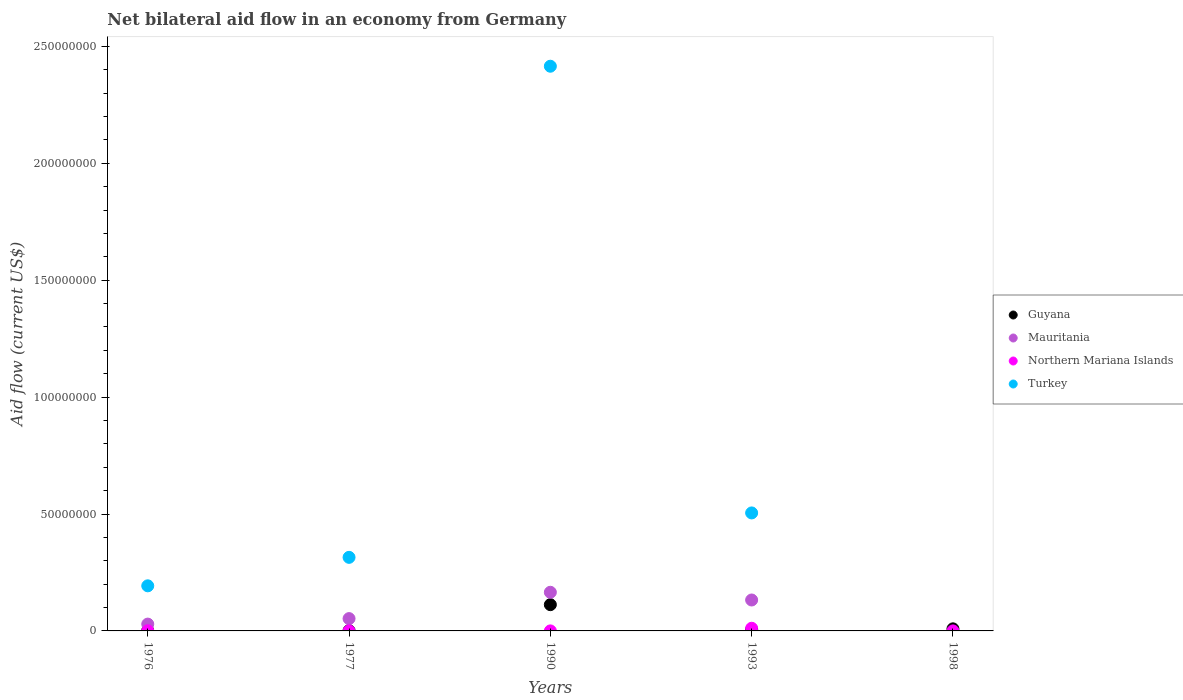What is the net bilateral aid flow in Mauritania in 1993?
Offer a terse response. 1.32e+07. Across all years, what is the maximum net bilateral aid flow in Northern Mariana Islands?
Offer a terse response. 1.14e+06. Across all years, what is the minimum net bilateral aid flow in Guyana?
Give a very brief answer. 1.20e+05. What is the total net bilateral aid flow in Northern Mariana Islands in the graph?
Your answer should be compact. 1.24e+06. What is the difference between the net bilateral aid flow in Turkey in 1976 and that in 1990?
Offer a very short reply. -2.22e+08. What is the difference between the net bilateral aid flow in Guyana in 1998 and the net bilateral aid flow in Northern Mariana Islands in 1977?
Provide a short and direct response. 8.80e+05. What is the average net bilateral aid flow in Northern Mariana Islands per year?
Make the answer very short. 2.48e+05. In the year 1993, what is the difference between the net bilateral aid flow in Mauritania and net bilateral aid flow in Guyana?
Your answer should be very brief. 1.27e+07. In how many years, is the net bilateral aid flow in Turkey greater than 140000000 US$?
Make the answer very short. 1. What is the ratio of the net bilateral aid flow in Turkey in 1976 to that in 1990?
Your answer should be very brief. 0.08. Is the difference between the net bilateral aid flow in Mauritania in 1976 and 1977 greater than the difference between the net bilateral aid flow in Guyana in 1976 and 1977?
Give a very brief answer. No. What is the difference between the highest and the second highest net bilateral aid flow in Northern Mariana Islands?
Give a very brief answer. 1.07e+06. What is the difference between the highest and the lowest net bilateral aid flow in Guyana?
Your response must be concise. 1.11e+07. In how many years, is the net bilateral aid flow in Turkey greater than the average net bilateral aid flow in Turkey taken over all years?
Ensure brevity in your answer.  1. Is the sum of the net bilateral aid flow in Turkey in 1990 and 1993 greater than the maximum net bilateral aid flow in Northern Mariana Islands across all years?
Your answer should be very brief. Yes. Does the net bilateral aid flow in Guyana monotonically increase over the years?
Provide a short and direct response. No. How many dotlines are there?
Your answer should be very brief. 4. How many years are there in the graph?
Give a very brief answer. 5. Are the values on the major ticks of Y-axis written in scientific E-notation?
Provide a succinct answer. No. Does the graph contain any zero values?
Offer a terse response. Yes. What is the title of the graph?
Your response must be concise. Net bilateral aid flow in an economy from Germany. Does "Singapore" appear as one of the legend labels in the graph?
Provide a succinct answer. No. What is the label or title of the X-axis?
Ensure brevity in your answer.  Years. What is the label or title of the Y-axis?
Offer a very short reply. Aid flow (current US$). What is the Aid flow (current US$) in Mauritania in 1976?
Your answer should be compact. 2.92e+06. What is the Aid flow (current US$) in Turkey in 1976?
Keep it short and to the point. 1.93e+07. What is the Aid flow (current US$) of Guyana in 1977?
Offer a very short reply. 1.20e+05. What is the Aid flow (current US$) of Mauritania in 1977?
Keep it short and to the point. 5.27e+06. What is the Aid flow (current US$) of Turkey in 1977?
Provide a short and direct response. 3.15e+07. What is the Aid flow (current US$) in Guyana in 1990?
Keep it short and to the point. 1.12e+07. What is the Aid flow (current US$) of Mauritania in 1990?
Keep it short and to the point. 1.65e+07. What is the Aid flow (current US$) in Northern Mariana Islands in 1990?
Provide a succinct answer. 10000. What is the Aid flow (current US$) in Turkey in 1990?
Your answer should be compact. 2.42e+08. What is the Aid flow (current US$) in Guyana in 1993?
Make the answer very short. 5.20e+05. What is the Aid flow (current US$) of Mauritania in 1993?
Your answer should be very brief. 1.32e+07. What is the Aid flow (current US$) in Northern Mariana Islands in 1993?
Ensure brevity in your answer.  1.14e+06. What is the Aid flow (current US$) in Turkey in 1993?
Ensure brevity in your answer.  5.05e+07. What is the Aid flow (current US$) of Guyana in 1998?
Ensure brevity in your answer.  8.90e+05. Across all years, what is the maximum Aid flow (current US$) of Guyana?
Ensure brevity in your answer.  1.12e+07. Across all years, what is the maximum Aid flow (current US$) in Mauritania?
Keep it short and to the point. 1.65e+07. Across all years, what is the maximum Aid flow (current US$) in Northern Mariana Islands?
Your response must be concise. 1.14e+06. Across all years, what is the maximum Aid flow (current US$) in Turkey?
Provide a short and direct response. 2.42e+08. Across all years, what is the minimum Aid flow (current US$) of Guyana?
Give a very brief answer. 1.20e+05. Across all years, what is the minimum Aid flow (current US$) of Northern Mariana Islands?
Give a very brief answer. 10000. What is the total Aid flow (current US$) in Guyana in the graph?
Provide a short and direct response. 1.29e+07. What is the total Aid flow (current US$) of Mauritania in the graph?
Make the answer very short. 3.80e+07. What is the total Aid flow (current US$) in Northern Mariana Islands in the graph?
Your answer should be compact. 1.24e+06. What is the total Aid flow (current US$) in Turkey in the graph?
Offer a terse response. 3.43e+08. What is the difference between the Aid flow (current US$) in Guyana in 1976 and that in 1977?
Give a very brief answer. 3.00e+04. What is the difference between the Aid flow (current US$) of Mauritania in 1976 and that in 1977?
Make the answer very short. -2.35e+06. What is the difference between the Aid flow (current US$) in Northern Mariana Islands in 1976 and that in 1977?
Make the answer very short. 6.00e+04. What is the difference between the Aid flow (current US$) of Turkey in 1976 and that in 1977?
Your response must be concise. -1.22e+07. What is the difference between the Aid flow (current US$) of Guyana in 1976 and that in 1990?
Your answer should be compact. -1.11e+07. What is the difference between the Aid flow (current US$) of Mauritania in 1976 and that in 1990?
Ensure brevity in your answer.  -1.36e+07. What is the difference between the Aid flow (current US$) of Northern Mariana Islands in 1976 and that in 1990?
Your answer should be compact. 6.00e+04. What is the difference between the Aid flow (current US$) in Turkey in 1976 and that in 1990?
Make the answer very short. -2.22e+08. What is the difference between the Aid flow (current US$) in Guyana in 1976 and that in 1993?
Your answer should be very brief. -3.70e+05. What is the difference between the Aid flow (current US$) in Mauritania in 1976 and that in 1993?
Provide a short and direct response. -1.03e+07. What is the difference between the Aid flow (current US$) of Northern Mariana Islands in 1976 and that in 1993?
Provide a short and direct response. -1.07e+06. What is the difference between the Aid flow (current US$) in Turkey in 1976 and that in 1993?
Give a very brief answer. -3.12e+07. What is the difference between the Aid flow (current US$) of Guyana in 1976 and that in 1998?
Ensure brevity in your answer.  -7.40e+05. What is the difference between the Aid flow (current US$) in Guyana in 1977 and that in 1990?
Make the answer very short. -1.11e+07. What is the difference between the Aid flow (current US$) in Mauritania in 1977 and that in 1990?
Ensure brevity in your answer.  -1.13e+07. What is the difference between the Aid flow (current US$) of Northern Mariana Islands in 1977 and that in 1990?
Provide a succinct answer. 0. What is the difference between the Aid flow (current US$) in Turkey in 1977 and that in 1990?
Your response must be concise. -2.10e+08. What is the difference between the Aid flow (current US$) of Guyana in 1977 and that in 1993?
Your answer should be compact. -4.00e+05. What is the difference between the Aid flow (current US$) in Mauritania in 1977 and that in 1993?
Provide a short and direct response. -7.96e+06. What is the difference between the Aid flow (current US$) of Northern Mariana Islands in 1977 and that in 1993?
Offer a very short reply. -1.13e+06. What is the difference between the Aid flow (current US$) in Turkey in 1977 and that in 1993?
Offer a terse response. -1.90e+07. What is the difference between the Aid flow (current US$) of Guyana in 1977 and that in 1998?
Provide a succinct answer. -7.70e+05. What is the difference between the Aid flow (current US$) in Northern Mariana Islands in 1977 and that in 1998?
Keep it short and to the point. 0. What is the difference between the Aid flow (current US$) in Guyana in 1990 and that in 1993?
Offer a terse response. 1.07e+07. What is the difference between the Aid flow (current US$) of Mauritania in 1990 and that in 1993?
Provide a short and direct response. 3.30e+06. What is the difference between the Aid flow (current US$) of Northern Mariana Islands in 1990 and that in 1993?
Offer a very short reply. -1.13e+06. What is the difference between the Aid flow (current US$) in Turkey in 1990 and that in 1993?
Provide a short and direct response. 1.91e+08. What is the difference between the Aid flow (current US$) in Guyana in 1990 and that in 1998?
Your answer should be compact. 1.03e+07. What is the difference between the Aid flow (current US$) of Guyana in 1993 and that in 1998?
Provide a succinct answer. -3.70e+05. What is the difference between the Aid flow (current US$) in Northern Mariana Islands in 1993 and that in 1998?
Ensure brevity in your answer.  1.13e+06. What is the difference between the Aid flow (current US$) in Guyana in 1976 and the Aid flow (current US$) in Mauritania in 1977?
Your answer should be very brief. -5.12e+06. What is the difference between the Aid flow (current US$) in Guyana in 1976 and the Aid flow (current US$) in Northern Mariana Islands in 1977?
Offer a very short reply. 1.40e+05. What is the difference between the Aid flow (current US$) of Guyana in 1976 and the Aid flow (current US$) of Turkey in 1977?
Your answer should be compact. -3.13e+07. What is the difference between the Aid flow (current US$) of Mauritania in 1976 and the Aid flow (current US$) of Northern Mariana Islands in 1977?
Provide a short and direct response. 2.91e+06. What is the difference between the Aid flow (current US$) of Mauritania in 1976 and the Aid flow (current US$) of Turkey in 1977?
Keep it short and to the point. -2.86e+07. What is the difference between the Aid flow (current US$) of Northern Mariana Islands in 1976 and the Aid flow (current US$) of Turkey in 1977?
Offer a terse response. -3.14e+07. What is the difference between the Aid flow (current US$) in Guyana in 1976 and the Aid flow (current US$) in Mauritania in 1990?
Your response must be concise. -1.64e+07. What is the difference between the Aid flow (current US$) in Guyana in 1976 and the Aid flow (current US$) in Turkey in 1990?
Offer a very short reply. -2.41e+08. What is the difference between the Aid flow (current US$) in Mauritania in 1976 and the Aid flow (current US$) in Northern Mariana Islands in 1990?
Make the answer very short. 2.91e+06. What is the difference between the Aid flow (current US$) in Mauritania in 1976 and the Aid flow (current US$) in Turkey in 1990?
Offer a terse response. -2.39e+08. What is the difference between the Aid flow (current US$) of Northern Mariana Islands in 1976 and the Aid flow (current US$) of Turkey in 1990?
Provide a short and direct response. -2.41e+08. What is the difference between the Aid flow (current US$) in Guyana in 1976 and the Aid flow (current US$) in Mauritania in 1993?
Give a very brief answer. -1.31e+07. What is the difference between the Aid flow (current US$) in Guyana in 1976 and the Aid flow (current US$) in Northern Mariana Islands in 1993?
Your response must be concise. -9.90e+05. What is the difference between the Aid flow (current US$) in Guyana in 1976 and the Aid flow (current US$) in Turkey in 1993?
Offer a terse response. -5.03e+07. What is the difference between the Aid flow (current US$) in Mauritania in 1976 and the Aid flow (current US$) in Northern Mariana Islands in 1993?
Offer a terse response. 1.78e+06. What is the difference between the Aid flow (current US$) of Mauritania in 1976 and the Aid flow (current US$) of Turkey in 1993?
Offer a terse response. -4.76e+07. What is the difference between the Aid flow (current US$) in Northern Mariana Islands in 1976 and the Aid flow (current US$) in Turkey in 1993?
Your answer should be compact. -5.04e+07. What is the difference between the Aid flow (current US$) of Guyana in 1976 and the Aid flow (current US$) of Northern Mariana Islands in 1998?
Provide a succinct answer. 1.40e+05. What is the difference between the Aid flow (current US$) in Mauritania in 1976 and the Aid flow (current US$) in Northern Mariana Islands in 1998?
Offer a terse response. 2.91e+06. What is the difference between the Aid flow (current US$) in Guyana in 1977 and the Aid flow (current US$) in Mauritania in 1990?
Make the answer very short. -1.64e+07. What is the difference between the Aid flow (current US$) of Guyana in 1977 and the Aid flow (current US$) of Northern Mariana Islands in 1990?
Offer a very short reply. 1.10e+05. What is the difference between the Aid flow (current US$) of Guyana in 1977 and the Aid flow (current US$) of Turkey in 1990?
Your answer should be very brief. -2.41e+08. What is the difference between the Aid flow (current US$) in Mauritania in 1977 and the Aid flow (current US$) in Northern Mariana Islands in 1990?
Offer a terse response. 5.26e+06. What is the difference between the Aid flow (current US$) in Mauritania in 1977 and the Aid flow (current US$) in Turkey in 1990?
Give a very brief answer. -2.36e+08. What is the difference between the Aid flow (current US$) of Northern Mariana Islands in 1977 and the Aid flow (current US$) of Turkey in 1990?
Make the answer very short. -2.42e+08. What is the difference between the Aid flow (current US$) in Guyana in 1977 and the Aid flow (current US$) in Mauritania in 1993?
Provide a short and direct response. -1.31e+07. What is the difference between the Aid flow (current US$) in Guyana in 1977 and the Aid flow (current US$) in Northern Mariana Islands in 1993?
Your answer should be compact. -1.02e+06. What is the difference between the Aid flow (current US$) of Guyana in 1977 and the Aid flow (current US$) of Turkey in 1993?
Your answer should be compact. -5.04e+07. What is the difference between the Aid flow (current US$) in Mauritania in 1977 and the Aid flow (current US$) in Northern Mariana Islands in 1993?
Your answer should be compact. 4.13e+06. What is the difference between the Aid flow (current US$) in Mauritania in 1977 and the Aid flow (current US$) in Turkey in 1993?
Your answer should be very brief. -4.52e+07. What is the difference between the Aid flow (current US$) in Northern Mariana Islands in 1977 and the Aid flow (current US$) in Turkey in 1993?
Your answer should be very brief. -5.05e+07. What is the difference between the Aid flow (current US$) of Mauritania in 1977 and the Aid flow (current US$) of Northern Mariana Islands in 1998?
Your answer should be compact. 5.26e+06. What is the difference between the Aid flow (current US$) in Guyana in 1990 and the Aid flow (current US$) in Northern Mariana Islands in 1993?
Your response must be concise. 1.01e+07. What is the difference between the Aid flow (current US$) of Guyana in 1990 and the Aid flow (current US$) of Turkey in 1993?
Provide a succinct answer. -3.92e+07. What is the difference between the Aid flow (current US$) of Mauritania in 1990 and the Aid flow (current US$) of Northern Mariana Islands in 1993?
Keep it short and to the point. 1.54e+07. What is the difference between the Aid flow (current US$) of Mauritania in 1990 and the Aid flow (current US$) of Turkey in 1993?
Ensure brevity in your answer.  -3.39e+07. What is the difference between the Aid flow (current US$) of Northern Mariana Islands in 1990 and the Aid flow (current US$) of Turkey in 1993?
Provide a short and direct response. -5.05e+07. What is the difference between the Aid flow (current US$) in Guyana in 1990 and the Aid flow (current US$) in Northern Mariana Islands in 1998?
Offer a terse response. 1.12e+07. What is the difference between the Aid flow (current US$) in Mauritania in 1990 and the Aid flow (current US$) in Northern Mariana Islands in 1998?
Your answer should be very brief. 1.65e+07. What is the difference between the Aid flow (current US$) in Guyana in 1993 and the Aid flow (current US$) in Northern Mariana Islands in 1998?
Your answer should be compact. 5.10e+05. What is the difference between the Aid flow (current US$) of Mauritania in 1993 and the Aid flow (current US$) of Northern Mariana Islands in 1998?
Keep it short and to the point. 1.32e+07. What is the average Aid flow (current US$) in Guyana per year?
Offer a terse response. 2.58e+06. What is the average Aid flow (current US$) of Mauritania per year?
Your response must be concise. 7.59e+06. What is the average Aid flow (current US$) of Northern Mariana Islands per year?
Give a very brief answer. 2.48e+05. What is the average Aid flow (current US$) of Turkey per year?
Offer a terse response. 6.86e+07. In the year 1976, what is the difference between the Aid flow (current US$) in Guyana and Aid flow (current US$) in Mauritania?
Offer a very short reply. -2.77e+06. In the year 1976, what is the difference between the Aid flow (current US$) in Guyana and Aid flow (current US$) in Turkey?
Offer a very short reply. -1.91e+07. In the year 1976, what is the difference between the Aid flow (current US$) in Mauritania and Aid flow (current US$) in Northern Mariana Islands?
Keep it short and to the point. 2.85e+06. In the year 1976, what is the difference between the Aid flow (current US$) in Mauritania and Aid flow (current US$) in Turkey?
Provide a short and direct response. -1.64e+07. In the year 1976, what is the difference between the Aid flow (current US$) of Northern Mariana Islands and Aid flow (current US$) of Turkey?
Provide a succinct answer. -1.92e+07. In the year 1977, what is the difference between the Aid flow (current US$) of Guyana and Aid flow (current US$) of Mauritania?
Provide a short and direct response. -5.15e+06. In the year 1977, what is the difference between the Aid flow (current US$) of Guyana and Aid flow (current US$) of Northern Mariana Islands?
Provide a succinct answer. 1.10e+05. In the year 1977, what is the difference between the Aid flow (current US$) in Guyana and Aid flow (current US$) in Turkey?
Make the answer very short. -3.14e+07. In the year 1977, what is the difference between the Aid flow (current US$) of Mauritania and Aid flow (current US$) of Northern Mariana Islands?
Ensure brevity in your answer.  5.26e+06. In the year 1977, what is the difference between the Aid flow (current US$) in Mauritania and Aid flow (current US$) in Turkey?
Provide a succinct answer. -2.62e+07. In the year 1977, what is the difference between the Aid flow (current US$) in Northern Mariana Islands and Aid flow (current US$) in Turkey?
Keep it short and to the point. -3.15e+07. In the year 1990, what is the difference between the Aid flow (current US$) of Guyana and Aid flow (current US$) of Mauritania?
Keep it short and to the point. -5.30e+06. In the year 1990, what is the difference between the Aid flow (current US$) of Guyana and Aid flow (current US$) of Northern Mariana Islands?
Provide a short and direct response. 1.12e+07. In the year 1990, what is the difference between the Aid flow (current US$) in Guyana and Aid flow (current US$) in Turkey?
Your answer should be compact. -2.30e+08. In the year 1990, what is the difference between the Aid flow (current US$) of Mauritania and Aid flow (current US$) of Northern Mariana Islands?
Your answer should be compact. 1.65e+07. In the year 1990, what is the difference between the Aid flow (current US$) in Mauritania and Aid flow (current US$) in Turkey?
Your response must be concise. -2.25e+08. In the year 1990, what is the difference between the Aid flow (current US$) of Northern Mariana Islands and Aid flow (current US$) of Turkey?
Your answer should be compact. -2.42e+08. In the year 1993, what is the difference between the Aid flow (current US$) of Guyana and Aid flow (current US$) of Mauritania?
Provide a short and direct response. -1.27e+07. In the year 1993, what is the difference between the Aid flow (current US$) of Guyana and Aid flow (current US$) of Northern Mariana Islands?
Your response must be concise. -6.20e+05. In the year 1993, what is the difference between the Aid flow (current US$) in Guyana and Aid flow (current US$) in Turkey?
Your response must be concise. -5.00e+07. In the year 1993, what is the difference between the Aid flow (current US$) of Mauritania and Aid flow (current US$) of Northern Mariana Islands?
Keep it short and to the point. 1.21e+07. In the year 1993, what is the difference between the Aid flow (current US$) in Mauritania and Aid flow (current US$) in Turkey?
Give a very brief answer. -3.72e+07. In the year 1993, what is the difference between the Aid flow (current US$) of Northern Mariana Islands and Aid flow (current US$) of Turkey?
Provide a short and direct response. -4.93e+07. In the year 1998, what is the difference between the Aid flow (current US$) in Guyana and Aid flow (current US$) in Northern Mariana Islands?
Offer a terse response. 8.80e+05. What is the ratio of the Aid flow (current US$) of Mauritania in 1976 to that in 1977?
Keep it short and to the point. 0.55. What is the ratio of the Aid flow (current US$) in Turkey in 1976 to that in 1977?
Your answer should be compact. 0.61. What is the ratio of the Aid flow (current US$) of Guyana in 1976 to that in 1990?
Offer a very short reply. 0.01. What is the ratio of the Aid flow (current US$) of Mauritania in 1976 to that in 1990?
Provide a short and direct response. 0.18. What is the ratio of the Aid flow (current US$) in Turkey in 1976 to that in 1990?
Your answer should be compact. 0.08. What is the ratio of the Aid flow (current US$) of Guyana in 1976 to that in 1993?
Provide a short and direct response. 0.29. What is the ratio of the Aid flow (current US$) in Mauritania in 1976 to that in 1993?
Your response must be concise. 0.22. What is the ratio of the Aid flow (current US$) of Northern Mariana Islands in 1976 to that in 1993?
Offer a very short reply. 0.06. What is the ratio of the Aid flow (current US$) in Turkey in 1976 to that in 1993?
Offer a very short reply. 0.38. What is the ratio of the Aid flow (current US$) in Guyana in 1976 to that in 1998?
Your answer should be compact. 0.17. What is the ratio of the Aid flow (current US$) in Northern Mariana Islands in 1976 to that in 1998?
Provide a short and direct response. 7. What is the ratio of the Aid flow (current US$) in Guyana in 1977 to that in 1990?
Give a very brief answer. 0.01. What is the ratio of the Aid flow (current US$) of Mauritania in 1977 to that in 1990?
Your answer should be very brief. 0.32. What is the ratio of the Aid flow (current US$) in Turkey in 1977 to that in 1990?
Your answer should be compact. 0.13. What is the ratio of the Aid flow (current US$) of Guyana in 1977 to that in 1993?
Ensure brevity in your answer.  0.23. What is the ratio of the Aid flow (current US$) of Mauritania in 1977 to that in 1993?
Your answer should be very brief. 0.4. What is the ratio of the Aid flow (current US$) of Northern Mariana Islands in 1977 to that in 1993?
Give a very brief answer. 0.01. What is the ratio of the Aid flow (current US$) in Turkey in 1977 to that in 1993?
Your answer should be very brief. 0.62. What is the ratio of the Aid flow (current US$) of Guyana in 1977 to that in 1998?
Your answer should be very brief. 0.13. What is the ratio of the Aid flow (current US$) of Northern Mariana Islands in 1977 to that in 1998?
Provide a short and direct response. 1. What is the ratio of the Aid flow (current US$) in Guyana in 1990 to that in 1993?
Ensure brevity in your answer.  21.6. What is the ratio of the Aid flow (current US$) of Mauritania in 1990 to that in 1993?
Your answer should be very brief. 1.25. What is the ratio of the Aid flow (current US$) of Northern Mariana Islands in 1990 to that in 1993?
Keep it short and to the point. 0.01. What is the ratio of the Aid flow (current US$) in Turkey in 1990 to that in 1993?
Your answer should be compact. 4.79. What is the ratio of the Aid flow (current US$) of Guyana in 1990 to that in 1998?
Your answer should be very brief. 12.62. What is the ratio of the Aid flow (current US$) in Guyana in 1993 to that in 1998?
Offer a terse response. 0.58. What is the ratio of the Aid flow (current US$) in Northern Mariana Islands in 1993 to that in 1998?
Provide a succinct answer. 114. What is the difference between the highest and the second highest Aid flow (current US$) in Guyana?
Make the answer very short. 1.03e+07. What is the difference between the highest and the second highest Aid flow (current US$) of Mauritania?
Ensure brevity in your answer.  3.30e+06. What is the difference between the highest and the second highest Aid flow (current US$) of Northern Mariana Islands?
Make the answer very short. 1.07e+06. What is the difference between the highest and the second highest Aid flow (current US$) in Turkey?
Offer a very short reply. 1.91e+08. What is the difference between the highest and the lowest Aid flow (current US$) in Guyana?
Offer a very short reply. 1.11e+07. What is the difference between the highest and the lowest Aid flow (current US$) of Mauritania?
Ensure brevity in your answer.  1.65e+07. What is the difference between the highest and the lowest Aid flow (current US$) of Northern Mariana Islands?
Your answer should be compact. 1.13e+06. What is the difference between the highest and the lowest Aid flow (current US$) in Turkey?
Provide a succinct answer. 2.42e+08. 